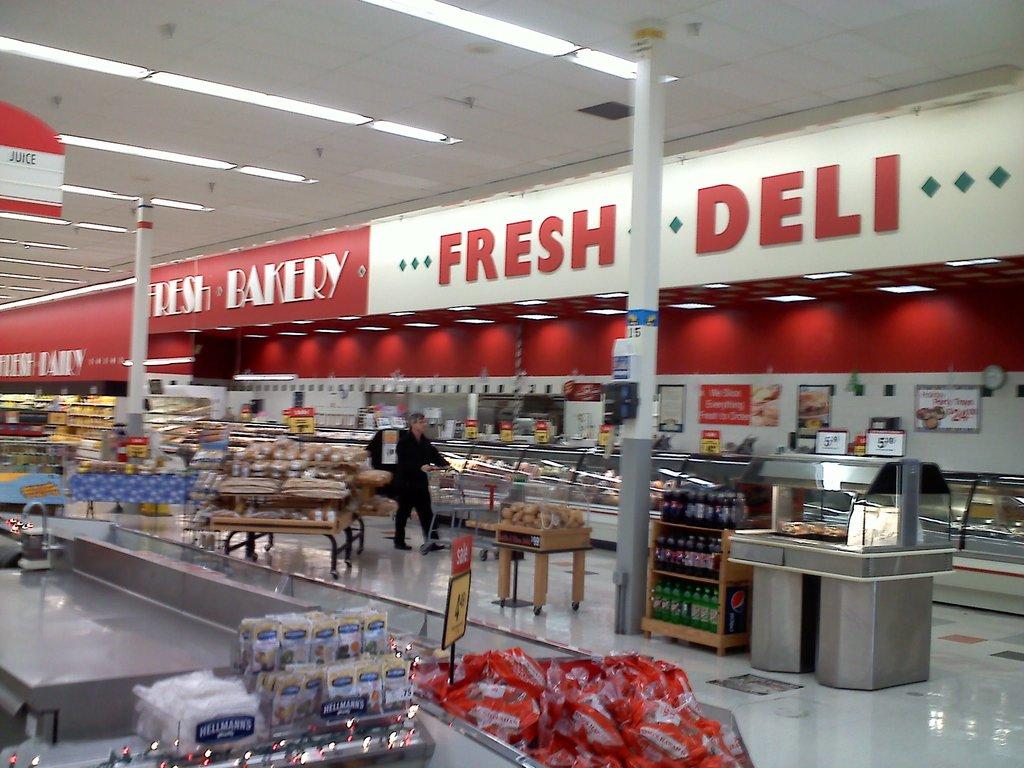Is there a deli in the building?
Your answer should be very brief. Yes. What type of bakery is it?
Offer a very short reply. Fresh. 